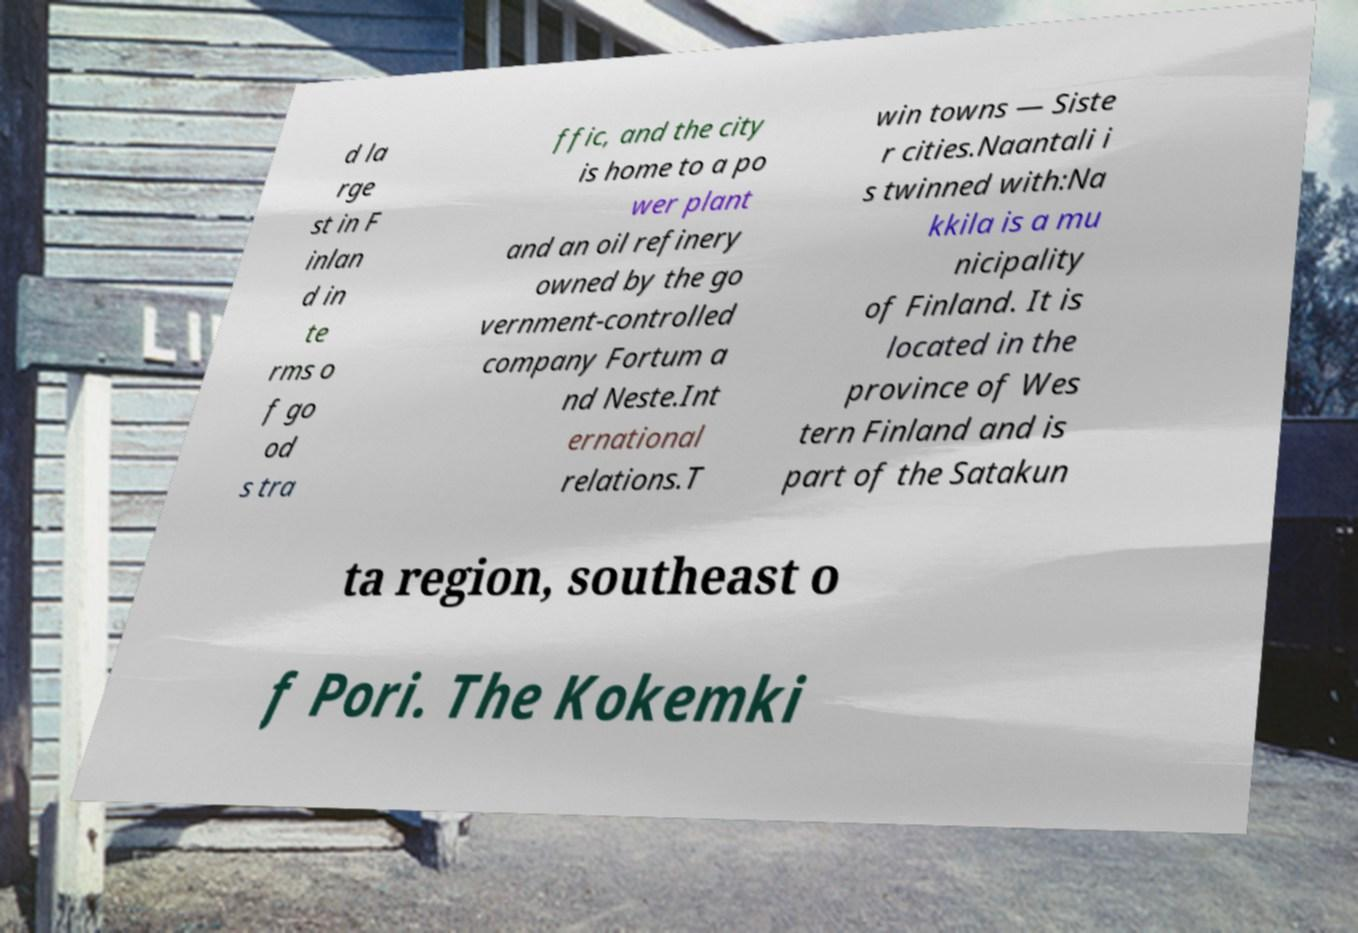Could you extract and type out the text from this image? d la rge st in F inlan d in te rms o f go od s tra ffic, and the city is home to a po wer plant and an oil refinery owned by the go vernment-controlled company Fortum a nd Neste.Int ernational relations.T win towns — Siste r cities.Naantali i s twinned with:Na kkila is a mu nicipality of Finland. It is located in the province of Wes tern Finland and is part of the Satakun ta region, southeast o f Pori. The Kokemki 